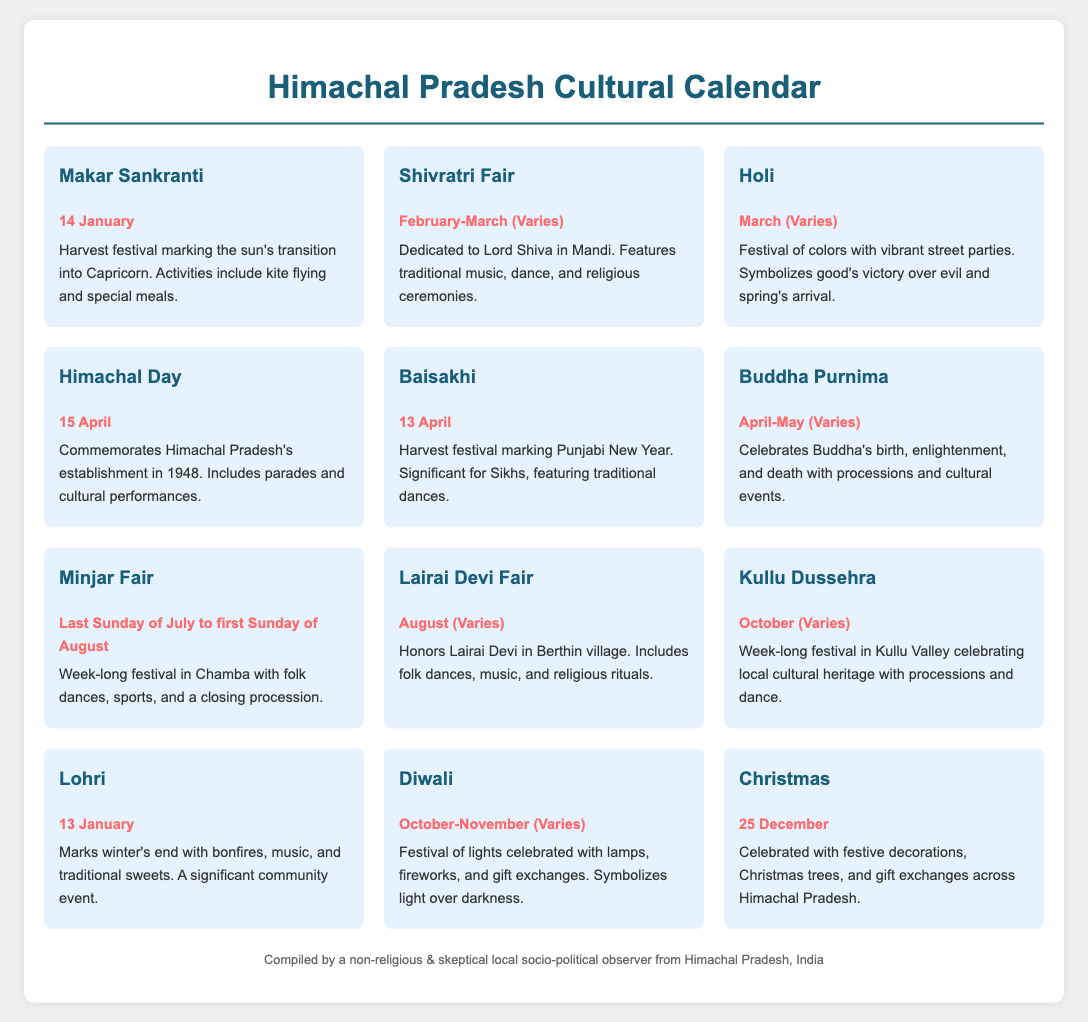What is the date of Makar Sankranti? Makar Sankranti is celebrated on January 14.
Answer: January 14 What festival marks the Punjabi New Year? The festival that marks the Punjabi New Year is Baisakhi.
Answer: Baisakhi Which month is Kullu Dussehra celebrated in? Kullu Dussehra is celebrated in October.
Answer: October What is the main activity during the Shivratri Fair? The main activities during the Shivratri Fair include traditional music, dance, and religious ceremonies.
Answer: Traditional music, dance, and religious ceremonies When does the Minjar Fair occur? The Minjar Fair occurs from the last Sunday of July to the first Sunday of August.
Answer: Last Sunday of July to first Sunday of August Which festival is celebrated on December 25? The festival celebrated on December 25 is Christmas.
Answer: Christmas What is the significance of Holi? Holi signifies the victory of good over evil and the arrival of spring.
Answer: Victory of good over evil and spring's arrival How is Diwali commonly celebrated? Diwali is commonly celebrated with lamps, fireworks, and gift exchanges.
Answer: Lamps, fireworks, and gift exchanges 